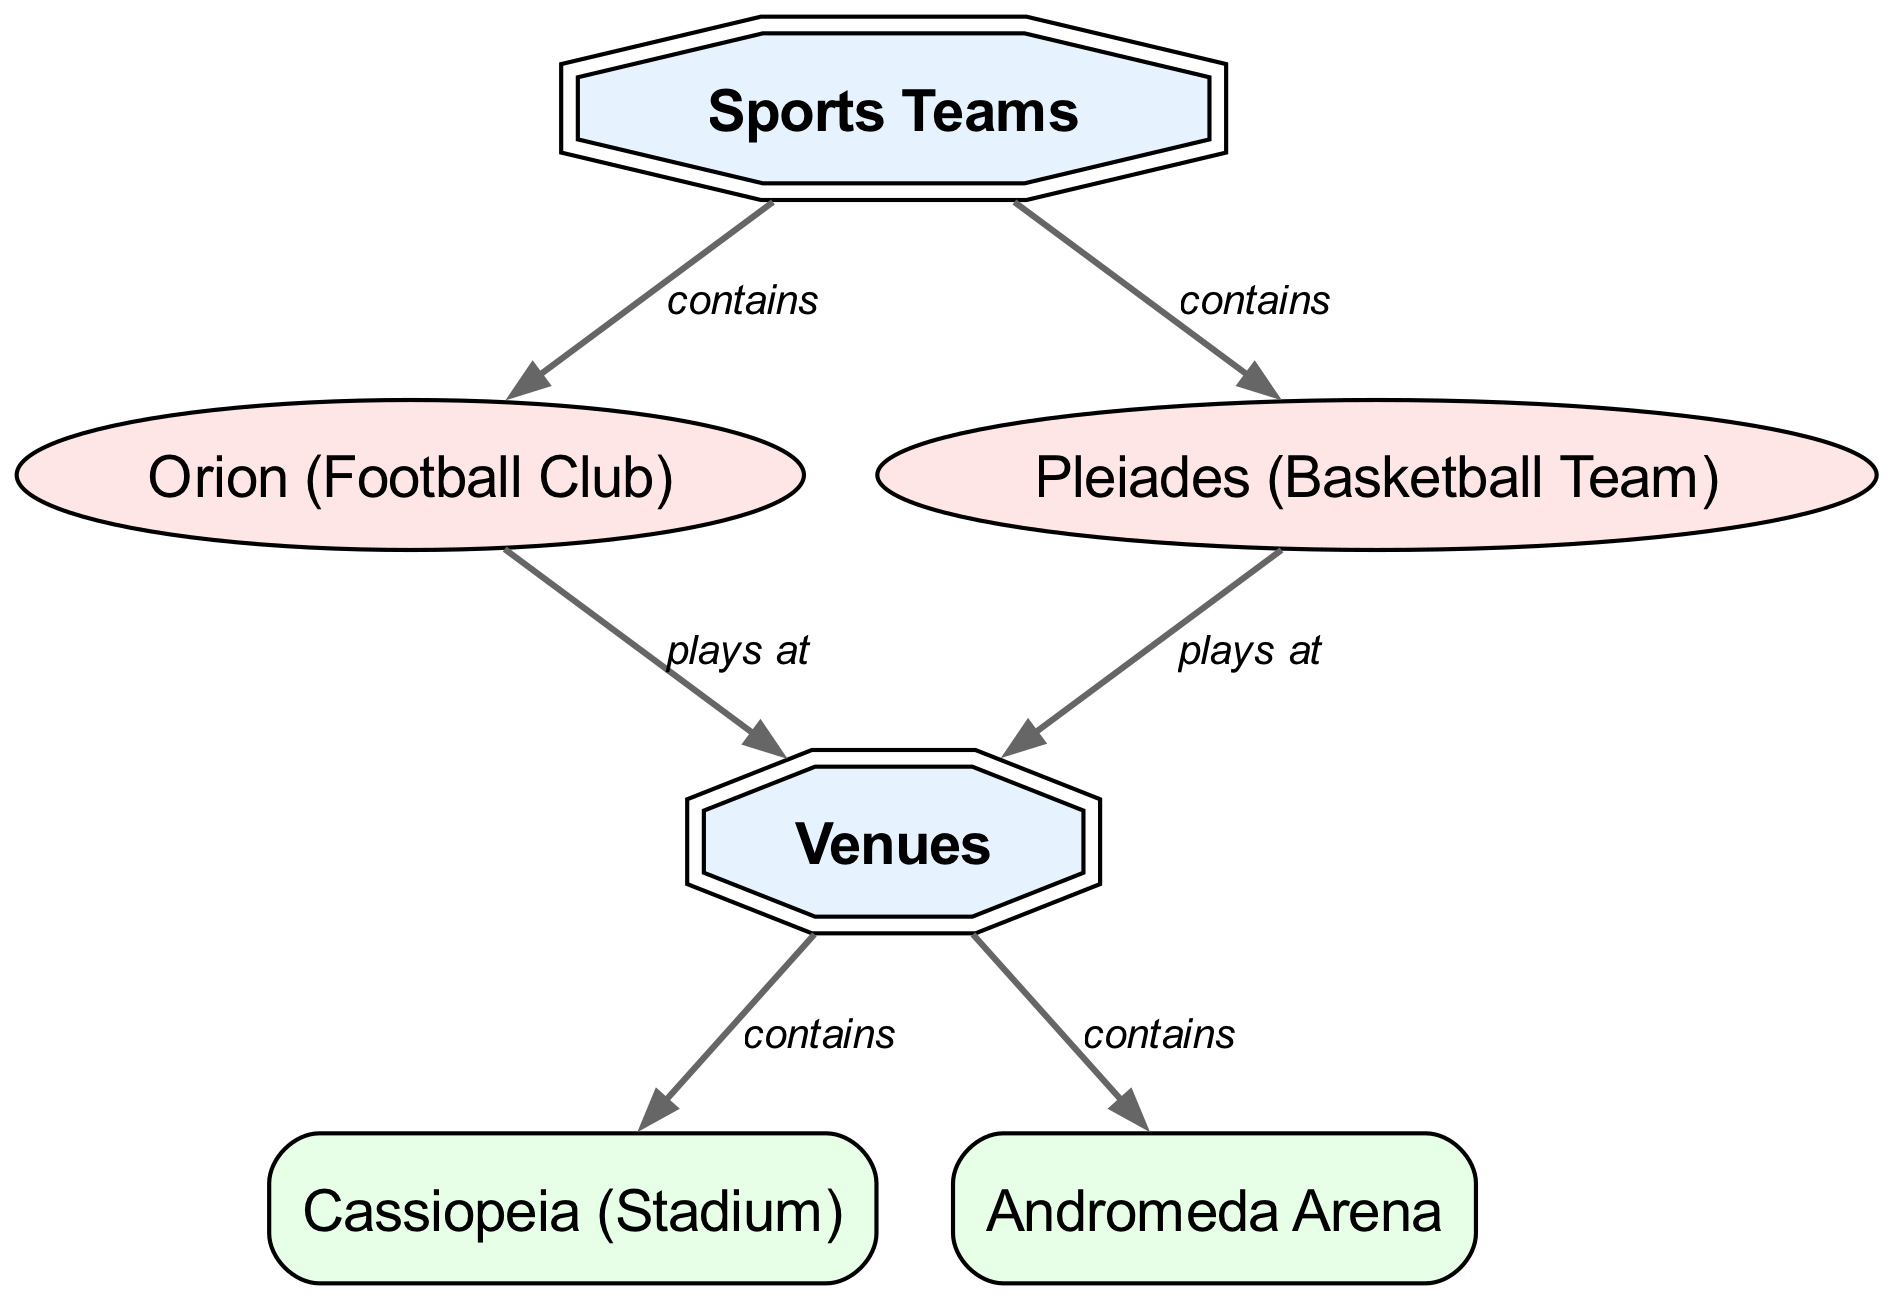What sports teams are represented in this diagram? The diagram lists two sports teams: Orion and Pleiades under the category "Sports Teams".
Answer: Orion, Pleiades How many venues are depicted in the diagram? There are two venues shown in the diagram: Cassiopeia and Andromeda under the category "Venues".
Answer: 2 What type of connection is shown between Orion and the venues? Orion is connected to the venues with the label "plays at", indicating where the team plays their games.
Answer: plays at Which venue is associated with Cassiopeia? Cassiopeia is specifically labeled as a venue in the diagram, placing it under the "Venues" category.
Answer: Cassiopeia How many teams play at venues in the diagram? Both listed teams (Orion and Pleiades) have a relationship indicating they play at venues, amounting to two teams playing at venues overall.
Answer: 2 Which constellation is connected to the Andromeda venue? The diagram connects the venue Andromeda to the "Venues" category, and a team is not indicated to directly connect with this venue specifically.
Answer: None What relationship does Pleiades have with venues in the diagram? Pleiades is shown to interact with venues under the connection labeled "plays at". This indicates it, like Orion, plays at a venue.
Answer: plays at How many connections are labeled as "contains" in the diagram? There are four connections labeled "contains", linking both sports teams to their respective category and venues to their category.
Answer: 4 Which team is associated with the Orion constellation? The diagram names the football club as Orion, directly linking it to the category of sports teams connecting to its astronomic name.
Answer: Orion 